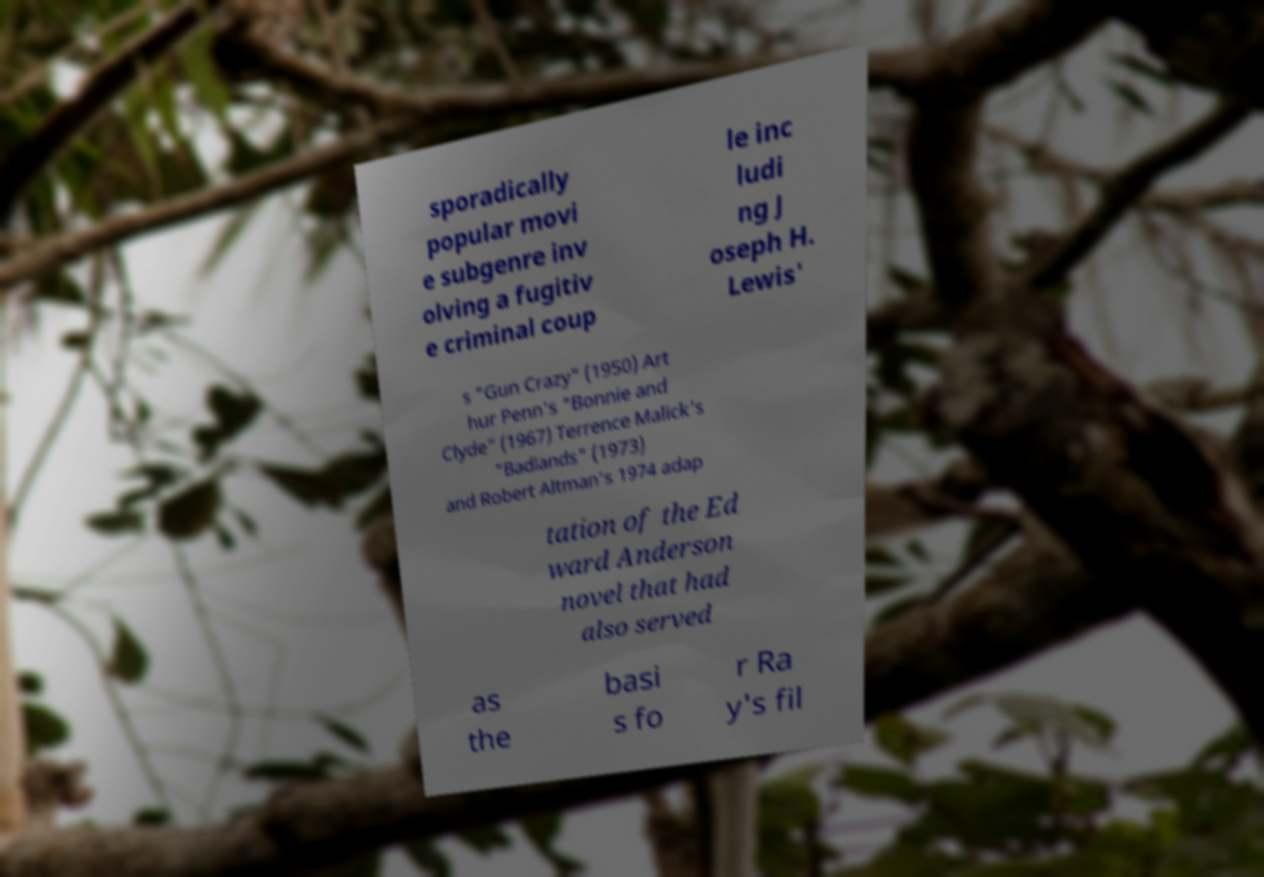Can you read and provide the text displayed in the image?This photo seems to have some interesting text. Can you extract and type it out for me? sporadically popular movi e subgenre inv olving a fugitiv e criminal coup le inc ludi ng J oseph H. Lewis' s "Gun Crazy" (1950) Art hur Penn's "Bonnie and Clyde" (1967) Terrence Malick's "Badlands" (1973) and Robert Altman's 1974 adap tation of the Ed ward Anderson novel that had also served as the basi s fo r Ra y's fil 